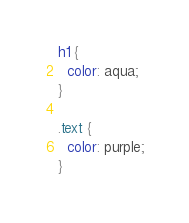Convert code to text. <code><loc_0><loc_0><loc_500><loc_500><_CSS_>h1 {
  color: aqua;
}

.text {
  color: purple;
}
</code> 